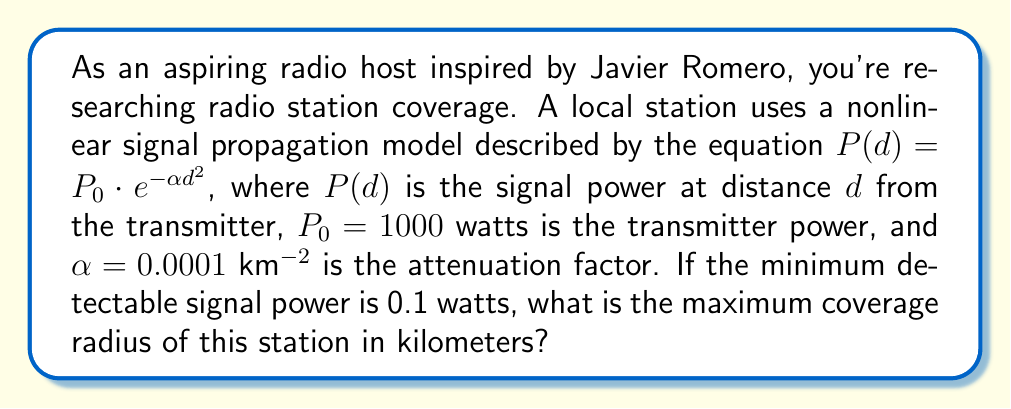Can you answer this question? To solve this problem, we'll follow these steps:

1) The given nonlinear signal propagation model is:
   $$P(d) = P_0 \cdot e^{-\alpha d^2}$$

2) We know:
   $P_0 = 1000$ watts
   $\alpha = 0.0001$ km^(-2)
   $P(d) = 0.1$ watts (minimum detectable signal power)

3) Substitute these values into the equation:
   $$0.1 = 1000 \cdot e^{-0.0001d^2}$$

4) Divide both sides by 1000:
   $$0.0001 = e^{-0.0001d^2}$$

5) Take the natural logarithm of both sides:
   $$\ln(0.0001) = -0.0001d^2$$

6) Simplify:
   $$-9.21 = -0.0001d^2$$

7) Divide both sides by -0.0001:
   $$92100 = d^2$$

8) Take the square root of both sides:
   $$d = \sqrt{92100} \approx 303.48$$

Therefore, the maximum coverage radius is approximately 303.48 km.
Answer: 303.48 km 